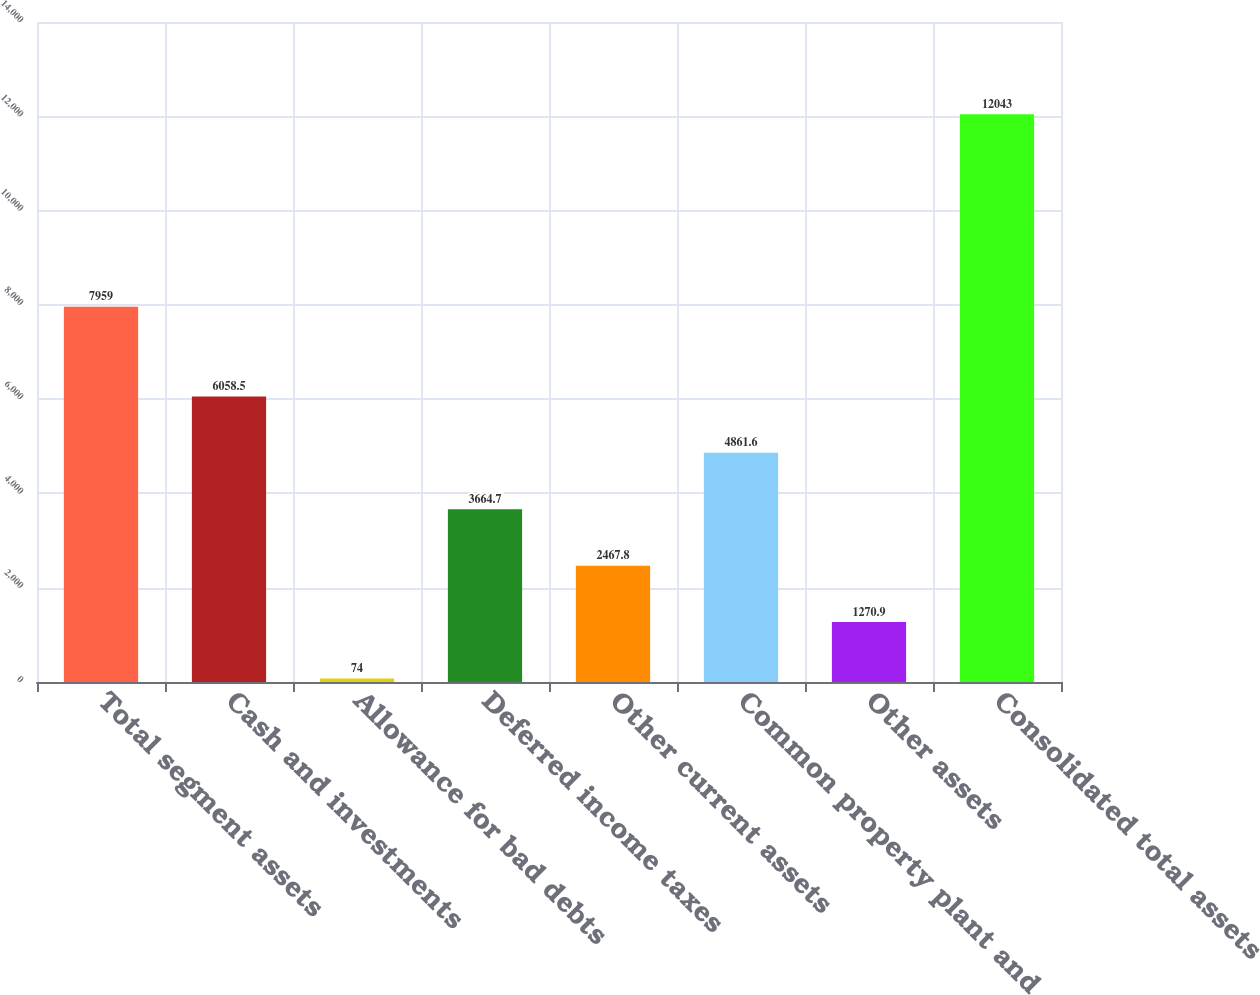<chart> <loc_0><loc_0><loc_500><loc_500><bar_chart><fcel>Total segment assets<fcel>Cash and investments<fcel>Allowance for bad debts<fcel>Deferred income taxes<fcel>Other current assets<fcel>Common property plant and<fcel>Other assets<fcel>Consolidated total assets<nl><fcel>7959<fcel>6058.5<fcel>74<fcel>3664.7<fcel>2467.8<fcel>4861.6<fcel>1270.9<fcel>12043<nl></chart> 